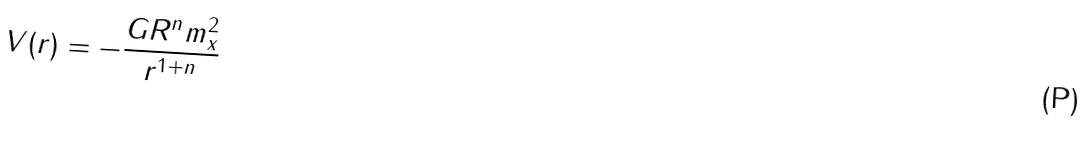Convert formula to latex. <formula><loc_0><loc_0><loc_500><loc_500>V ( r ) = - \frac { G R ^ { n } m _ { x } ^ { 2 } } { r ^ { 1 + n } }</formula> 